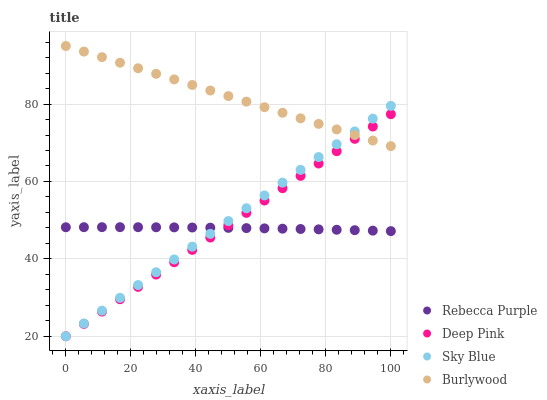Does Rebecca Purple have the minimum area under the curve?
Answer yes or no. Yes. Does Burlywood have the maximum area under the curve?
Answer yes or no. Yes. Does Sky Blue have the minimum area under the curve?
Answer yes or no. No. Does Sky Blue have the maximum area under the curve?
Answer yes or no. No. Is Burlywood the smoothest?
Answer yes or no. Yes. Is Rebecca Purple the roughest?
Answer yes or no. Yes. Is Sky Blue the smoothest?
Answer yes or no. No. Is Sky Blue the roughest?
Answer yes or no. No. Does Sky Blue have the lowest value?
Answer yes or no. Yes. Does Rebecca Purple have the lowest value?
Answer yes or no. No. Does Burlywood have the highest value?
Answer yes or no. Yes. Does Sky Blue have the highest value?
Answer yes or no. No. Is Rebecca Purple less than Burlywood?
Answer yes or no. Yes. Is Burlywood greater than Rebecca Purple?
Answer yes or no. Yes. Does Rebecca Purple intersect Deep Pink?
Answer yes or no. Yes. Is Rebecca Purple less than Deep Pink?
Answer yes or no. No. Is Rebecca Purple greater than Deep Pink?
Answer yes or no. No. Does Rebecca Purple intersect Burlywood?
Answer yes or no. No. 